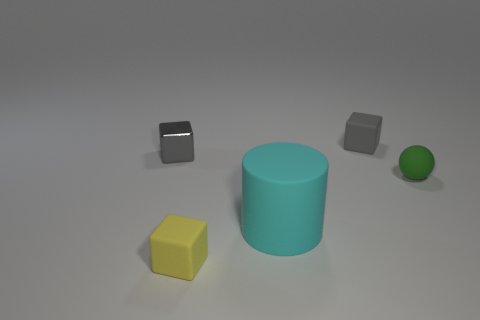Add 3 cylinders. How many objects exist? 8 Subtract all balls. How many objects are left? 4 Add 1 cyan rubber objects. How many cyan rubber objects are left? 2 Add 5 cylinders. How many cylinders exist? 6 Subtract 0 brown spheres. How many objects are left? 5 Subtract all tiny green rubber things. Subtract all green things. How many objects are left? 3 